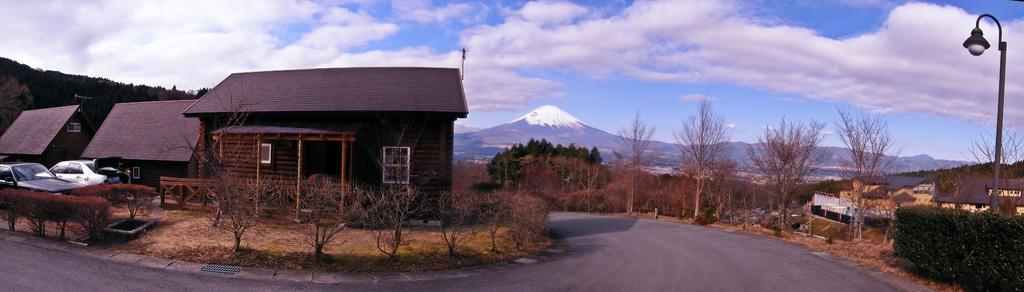What type of pathway is visible in the image? There is a road in the image. What type of vegetation can be seen in the image? There are trees in the image. What type of structures are present in the image? There are houses with windows in the image. What type of object can be seen supporting something else in the image? There is a pole in the image. What type of illumination is present in the image? There is a light in the image. What type of vehicles can be seen in the image? There are cars in the image. What type of natural landform is visible in the image? There are mountains in the image. What is visible in the background of the image? The sky with clouds is visible in the background of the image. Can you tell me how many pigs are running across the road in the image? There are no pigs present in the image. What type of process is being carried out by the cars in the image? The cars in the image are not performing any process; they are simply parked or driving. 